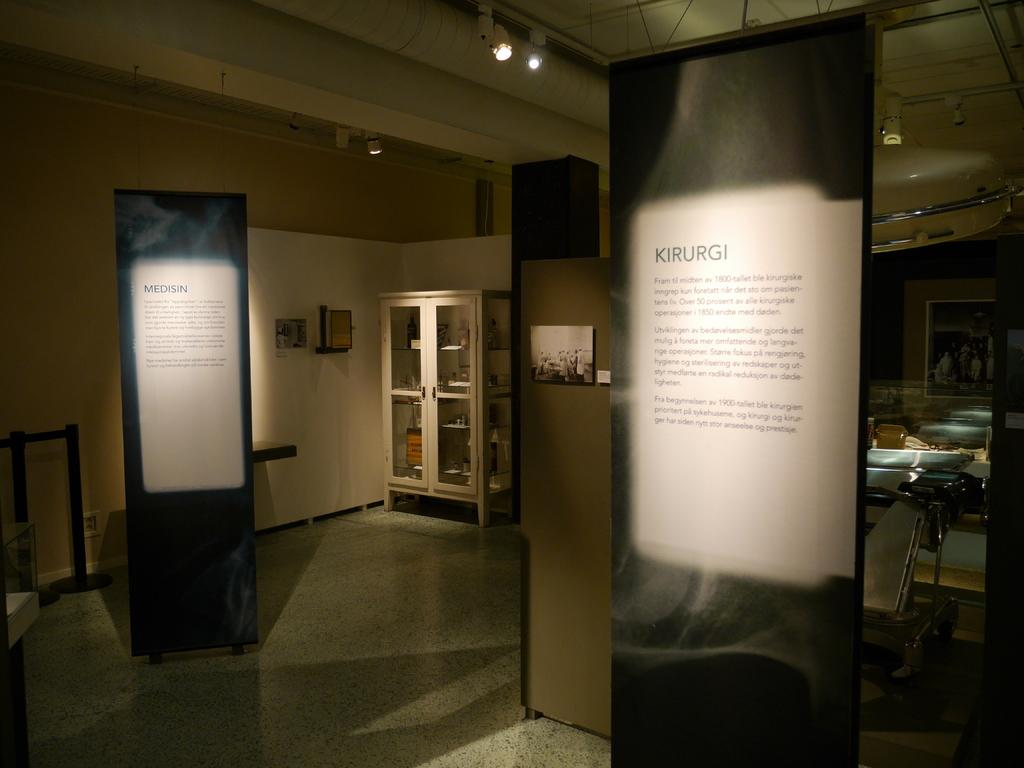What is placed on the path in the image? There are boards on the path in the image. What is located behind the boards? There is a cupboard behind the boards. What can be seen on the wall behind the boards? There is a wall with photos behind the boards. What type of lighting is present in the image? Ceiling lights are visible in the image. How many dolls are being taught in the image? There are no dolls or teaching activities present in the image. 